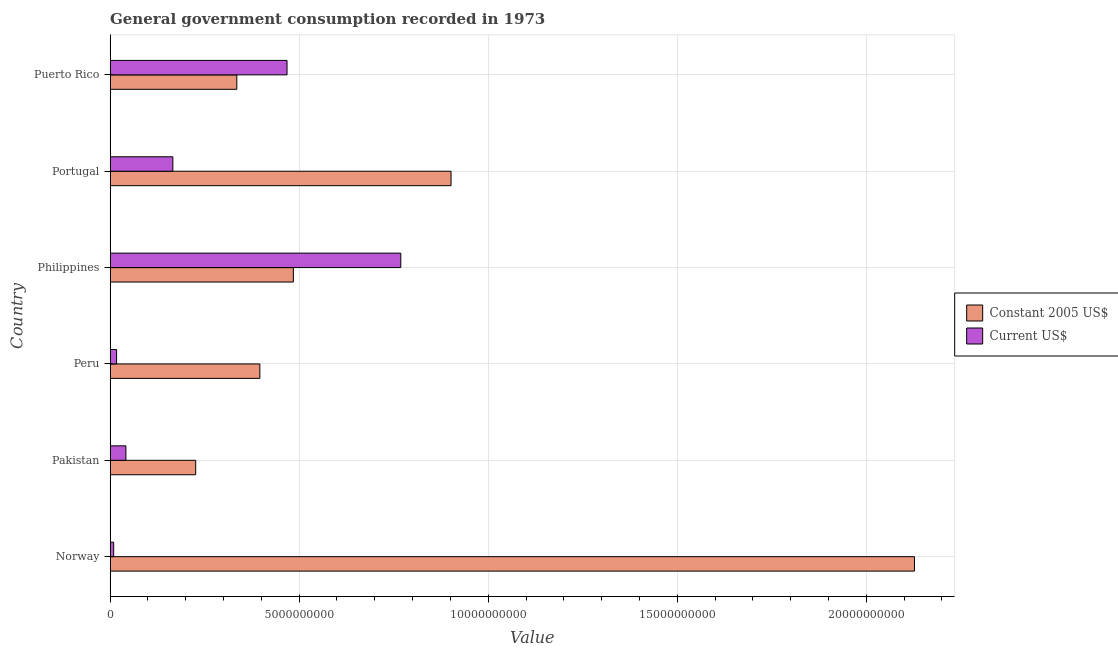How many different coloured bars are there?
Make the answer very short. 2. Are the number of bars per tick equal to the number of legend labels?
Keep it short and to the point. Yes. In how many cases, is the number of bars for a given country not equal to the number of legend labels?
Offer a terse response. 0. What is the value consumed in current us$ in Norway?
Provide a succinct answer. 9.30e+07. Across all countries, what is the maximum value consumed in constant 2005 us$?
Provide a succinct answer. 2.13e+1. Across all countries, what is the minimum value consumed in current us$?
Your response must be concise. 9.30e+07. In which country was the value consumed in constant 2005 us$ maximum?
Offer a very short reply. Norway. What is the total value consumed in constant 2005 us$ in the graph?
Make the answer very short. 4.47e+1. What is the difference between the value consumed in constant 2005 us$ in Peru and that in Portugal?
Provide a short and direct response. -5.06e+09. What is the difference between the value consumed in current us$ in Norway and the value consumed in constant 2005 us$ in Puerto Rico?
Provide a succinct answer. -3.26e+09. What is the average value consumed in current us$ per country?
Your answer should be very brief. 2.45e+09. What is the difference between the value consumed in current us$ and value consumed in constant 2005 us$ in Puerto Rico?
Provide a short and direct response. 1.33e+09. In how many countries, is the value consumed in constant 2005 us$ greater than 19000000000 ?
Give a very brief answer. 1. What is the ratio of the value consumed in constant 2005 us$ in Pakistan to that in Philippines?
Provide a succinct answer. 0.47. What is the difference between the highest and the second highest value consumed in constant 2005 us$?
Make the answer very short. 1.23e+1. What is the difference between the highest and the lowest value consumed in current us$?
Keep it short and to the point. 7.59e+09. In how many countries, is the value consumed in current us$ greater than the average value consumed in current us$ taken over all countries?
Ensure brevity in your answer.  2. What does the 1st bar from the top in Pakistan represents?
Offer a very short reply. Current US$. What does the 2nd bar from the bottom in Philippines represents?
Keep it short and to the point. Current US$. Are all the bars in the graph horizontal?
Keep it short and to the point. Yes. Are the values on the major ticks of X-axis written in scientific E-notation?
Your answer should be compact. No. How many legend labels are there?
Provide a succinct answer. 2. How are the legend labels stacked?
Your answer should be very brief. Vertical. What is the title of the graph?
Ensure brevity in your answer.  General government consumption recorded in 1973. Does "Grants" appear as one of the legend labels in the graph?
Offer a terse response. No. What is the label or title of the X-axis?
Keep it short and to the point. Value. What is the Value of Constant 2005 US$ in Norway?
Offer a terse response. 2.13e+1. What is the Value in Current US$ in Norway?
Make the answer very short. 9.30e+07. What is the Value of Constant 2005 US$ in Pakistan?
Ensure brevity in your answer.  2.26e+09. What is the Value in Current US$ in Pakistan?
Keep it short and to the point. 4.17e+08. What is the Value of Constant 2005 US$ in Peru?
Offer a terse response. 3.96e+09. What is the Value in Current US$ in Peru?
Offer a terse response. 1.70e+08. What is the Value of Constant 2005 US$ in Philippines?
Give a very brief answer. 4.85e+09. What is the Value in Current US$ in Philippines?
Offer a terse response. 7.69e+09. What is the Value of Constant 2005 US$ in Portugal?
Offer a terse response. 9.02e+09. What is the Value in Current US$ in Portugal?
Your answer should be very brief. 1.66e+09. What is the Value of Constant 2005 US$ in Puerto Rico?
Make the answer very short. 3.35e+09. What is the Value of Current US$ in Puerto Rico?
Offer a very short reply. 4.68e+09. Across all countries, what is the maximum Value in Constant 2005 US$?
Ensure brevity in your answer.  2.13e+1. Across all countries, what is the maximum Value of Current US$?
Ensure brevity in your answer.  7.69e+09. Across all countries, what is the minimum Value in Constant 2005 US$?
Ensure brevity in your answer.  2.26e+09. Across all countries, what is the minimum Value in Current US$?
Offer a very short reply. 9.30e+07. What is the total Value in Constant 2005 US$ in the graph?
Ensure brevity in your answer.  4.47e+1. What is the total Value in Current US$ in the graph?
Give a very brief answer. 1.47e+1. What is the difference between the Value in Constant 2005 US$ in Norway and that in Pakistan?
Offer a terse response. 1.90e+1. What is the difference between the Value of Current US$ in Norway and that in Pakistan?
Offer a very short reply. -3.24e+08. What is the difference between the Value in Constant 2005 US$ in Norway and that in Peru?
Ensure brevity in your answer.  1.73e+1. What is the difference between the Value of Current US$ in Norway and that in Peru?
Keep it short and to the point. -7.70e+07. What is the difference between the Value of Constant 2005 US$ in Norway and that in Philippines?
Provide a short and direct response. 1.64e+1. What is the difference between the Value in Current US$ in Norway and that in Philippines?
Offer a very short reply. -7.59e+09. What is the difference between the Value of Constant 2005 US$ in Norway and that in Portugal?
Provide a short and direct response. 1.23e+1. What is the difference between the Value in Current US$ in Norway and that in Portugal?
Provide a succinct answer. -1.57e+09. What is the difference between the Value in Constant 2005 US$ in Norway and that in Puerto Rico?
Give a very brief answer. 1.79e+1. What is the difference between the Value of Current US$ in Norway and that in Puerto Rico?
Provide a short and direct response. -4.59e+09. What is the difference between the Value of Constant 2005 US$ in Pakistan and that in Peru?
Keep it short and to the point. -1.70e+09. What is the difference between the Value of Current US$ in Pakistan and that in Peru?
Your answer should be compact. 2.47e+08. What is the difference between the Value of Constant 2005 US$ in Pakistan and that in Philippines?
Make the answer very short. -2.58e+09. What is the difference between the Value of Current US$ in Pakistan and that in Philippines?
Ensure brevity in your answer.  -7.27e+09. What is the difference between the Value of Constant 2005 US$ in Pakistan and that in Portugal?
Your response must be concise. -6.75e+09. What is the difference between the Value in Current US$ in Pakistan and that in Portugal?
Your answer should be very brief. -1.24e+09. What is the difference between the Value of Constant 2005 US$ in Pakistan and that in Puerto Rico?
Your answer should be compact. -1.09e+09. What is the difference between the Value of Current US$ in Pakistan and that in Puerto Rico?
Keep it short and to the point. -4.26e+09. What is the difference between the Value in Constant 2005 US$ in Peru and that in Philippines?
Offer a very short reply. -8.87e+08. What is the difference between the Value in Current US$ in Peru and that in Philippines?
Make the answer very short. -7.52e+09. What is the difference between the Value of Constant 2005 US$ in Peru and that in Portugal?
Provide a short and direct response. -5.06e+09. What is the difference between the Value of Current US$ in Peru and that in Portugal?
Give a very brief answer. -1.49e+09. What is the difference between the Value in Constant 2005 US$ in Peru and that in Puerto Rico?
Offer a very short reply. 6.09e+08. What is the difference between the Value in Current US$ in Peru and that in Puerto Rico?
Your answer should be compact. -4.51e+09. What is the difference between the Value in Constant 2005 US$ in Philippines and that in Portugal?
Give a very brief answer. -4.17e+09. What is the difference between the Value of Current US$ in Philippines and that in Portugal?
Your response must be concise. 6.03e+09. What is the difference between the Value of Constant 2005 US$ in Philippines and that in Puerto Rico?
Keep it short and to the point. 1.50e+09. What is the difference between the Value in Current US$ in Philippines and that in Puerto Rico?
Provide a succinct answer. 3.01e+09. What is the difference between the Value in Constant 2005 US$ in Portugal and that in Puerto Rico?
Your answer should be very brief. 5.67e+09. What is the difference between the Value of Current US$ in Portugal and that in Puerto Rico?
Your answer should be very brief. -3.02e+09. What is the difference between the Value in Constant 2005 US$ in Norway and the Value in Current US$ in Pakistan?
Your answer should be compact. 2.09e+1. What is the difference between the Value in Constant 2005 US$ in Norway and the Value in Current US$ in Peru?
Provide a short and direct response. 2.11e+1. What is the difference between the Value of Constant 2005 US$ in Norway and the Value of Current US$ in Philippines?
Offer a very short reply. 1.36e+1. What is the difference between the Value in Constant 2005 US$ in Norway and the Value in Current US$ in Portugal?
Make the answer very short. 1.96e+1. What is the difference between the Value of Constant 2005 US$ in Norway and the Value of Current US$ in Puerto Rico?
Your answer should be very brief. 1.66e+1. What is the difference between the Value of Constant 2005 US$ in Pakistan and the Value of Current US$ in Peru?
Your response must be concise. 2.09e+09. What is the difference between the Value in Constant 2005 US$ in Pakistan and the Value in Current US$ in Philippines?
Ensure brevity in your answer.  -5.43e+09. What is the difference between the Value in Constant 2005 US$ in Pakistan and the Value in Current US$ in Portugal?
Offer a terse response. 6.04e+08. What is the difference between the Value in Constant 2005 US$ in Pakistan and the Value in Current US$ in Puerto Rico?
Give a very brief answer. -2.42e+09. What is the difference between the Value in Constant 2005 US$ in Peru and the Value in Current US$ in Philippines?
Give a very brief answer. -3.73e+09. What is the difference between the Value in Constant 2005 US$ in Peru and the Value in Current US$ in Portugal?
Give a very brief answer. 2.30e+09. What is the difference between the Value of Constant 2005 US$ in Peru and the Value of Current US$ in Puerto Rico?
Offer a very short reply. -7.19e+08. What is the difference between the Value of Constant 2005 US$ in Philippines and the Value of Current US$ in Portugal?
Ensure brevity in your answer.  3.19e+09. What is the difference between the Value of Constant 2005 US$ in Philippines and the Value of Current US$ in Puerto Rico?
Keep it short and to the point. 1.67e+08. What is the difference between the Value of Constant 2005 US$ in Portugal and the Value of Current US$ in Puerto Rico?
Your response must be concise. 4.34e+09. What is the average Value of Constant 2005 US$ per country?
Your response must be concise. 7.45e+09. What is the average Value in Current US$ per country?
Offer a terse response. 2.45e+09. What is the difference between the Value of Constant 2005 US$ and Value of Current US$ in Norway?
Ensure brevity in your answer.  2.12e+1. What is the difference between the Value of Constant 2005 US$ and Value of Current US$ in Pakistan?
Give a very brief answer. 1.85e+09. What is the difference between the Value in Constant 2005 US$ and Value in Current US$ in Peru?
Offer a very short reply. 3.79e+09. What is the difference between the Value of Constant 2005 US$ and Value of Current US$ in Philippines?
Offer a very short reply. -2.84e+09. What is the difference between the Value in Constant 2005 US$ and Value in Current US$ in Portugal?
Provide a short and direct response. 7.36e+09. What is the difference between the Value of Constant 2005 US$ and Value of Current US$ in Puerto Rico?
Offer a very short reply. -1.33e+09. What is the ratio of the Value of Constant 2005 US$ in Norway to that in Pakistan?
Your answer should be very brief. 9.4. What is the ratio of the Value of Current US$ in Norway to that in Pakistan?
Provide a succinct answer. 0.22. What is the ratio of the Value in Constant 2005 US$ in Norway to that in Peru?
Provide a short and direct response. 5.37. What is the ratio of the Value in Current US$ in Norway to that in Peru?
Your response must be concise. 0.55. What is the ratio of the Value of Constant 2005 US$ in Norway to that in Philippines?
Provide a succinct answer. 4.39. What is the ratio of the Value in Current US$ in Norway to that in Philippines?
Your response must be concise. 0.01. What is the ratio of the Value in Constant 2005 US$ in Norway to that in Portugal?
Keep it short and to the point. 2.36. What is the ratio of the Value of Current US$ in Norway to that in Portugal?
Provide a succinct answer. 0.06. What is the ratio of the Value in Constant 2005 US$ in Norway to that in Puerto Rico?
Offer a very short reply. 6.35. What is the ratio of the Value in Current US$ in Norway to that in Puerto Rico?
Offer a very short reply. 0.02. What is the ratio of the Value of Constant 2005 US$ in Pakistan to that in Peru?
Provide a short and direct response. 0.57. What is the ratio of the Value in Current US$ in Pakistan to that in Peru?
Offer a very short reply. 2.45. What is the ratio of the Value of Constant 2005 US$ in Pakistan to that in Philippines?
Give a very brief answer. 0.47. What is the ratio of the Value in Current US$ in Pakistan to that in Philippines?
Your answer should be compact. 0.05. What is the ratio of the Value of Constant 2005 US$ in Pakistan to that in Portugal?
Your answer should be compact. 0.25. What is the ratio of the Value of Current US$ in Pakistan to that in Portugal?
Give a very brief answer. 0.25. What is the ratio of the Value in Constant 2005 US$ in Pakistan to that in Puerto Rico?
Offer a terse response. 0.68. What is the ratio of the Value of Current US$ in Pakistan to that in Puerto Rico?
Provide a short and direct response. 0.09. What is the ratio of the Value in Constant 2005 US$ in Peru to that in Philippines?
Give a very brief answer. 0.82. What is the ratio of the Value in Current US$ in Peru to that in Philippines?
Provide a succinct answer. 0.02. What is the ratio of the Value in Constant 2005 US$ in Peru to that in Portugal?
Your response must be concise. 0.44. What is the ratio of the Value in Current US$ in Peru to that in Portugal?
Provide a succinct answer. 0.1. What is the ratio of the Value of Constant 2005 US$ in Peru to that in Puerto Rico?
Provide a succinct answer. 1.18. What is the ratio of the Value in Current US$ in Peru to that in Puerto Rico?
Keep it short and to the point. 0.04. What is the ratio of the Value of Constant 2005 US$ in Philippines to that in Portugal?
Ensure brevity in your answer.  0.54. What is the ratio of the Value in Current US$ in Philippines to that in Portugal?
Ensure brevity in your answer.  4.63. What is the ratio of the Value in Constant 2005 US$ in Philippines to that in Puerto Rico?
Keep it short and to the point. 1.45. What is the ratio of the Value in Current US$ in Philippines to that in Puerto Rico?
Offer a very short reply. 1.64. What is the ratio of the Value in Constant 2005 US$ in Portugal to that in Puerto Rico?
Your answer should be very brief. 2.69. What is the ratio of the Value of Current US$ in Portugal to that in Puerto Rico?
Your answer should be very brief. 0.35. What is the difference between the highest and the second highest Value of Constant 2005 US$?
Your answer should be very brief. 1.23e+1. What is the difference between the highest and the second highest Value of Current US$?
Ensure brevity in your answer.  3.01e+09. What is the difference between the highest and the lowest Value in Constant 2005 US$?
Your answer should be very brief. 1.90e+1. What is the difference between the highest and the lowest Value in Current US$?
Give a very brief answer. 7.59e+09. 